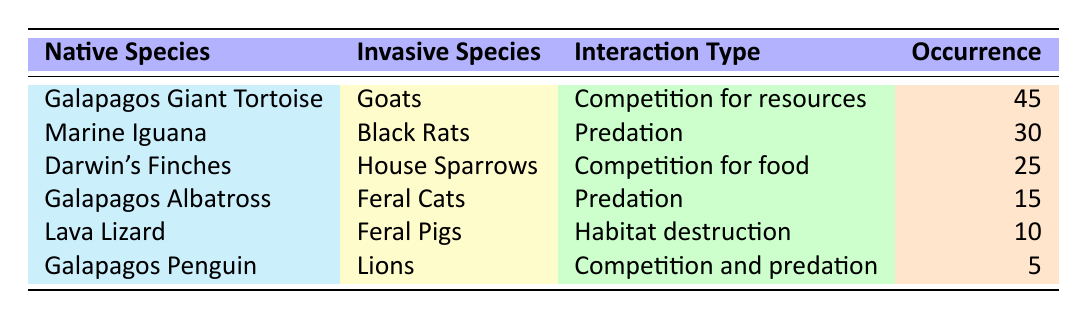What is the most common interaction type listed in the table? The interaction with the highest occurrence is "Competition for resources" between the Galapagos Giant Tortoise and Goats, which has an occurrence of 45. This is more than any other interaction listed.
Answer: Competition for resources How many occurrences are attributed to predation interactions? There are two predation interactions in the table: Marine Iguana with Black Rats (30 occurrences) and Galapagos Albatross with Feral Cats (15 occurrences). Adding these together gives 30 + 15 = 45 occurrences for predation.
Answer: 45 Is it true that invasive species cause habitat destruction for native species in the Galapagos? Yes, it is true, as indicated by the interaction between Lava Lizard and Feral Pigs, which is labeled as "Habitat destruction."
Answer: Yes Which native species has the least reported occurrences in interactions with invasive species? The Galapagos Penguin has the least occurrences with only 5, listed under the interaction "Competition and predation" with Lions.
Answer: Galapagos Penguin What is the total number of occurrences for all types of interactions in the table? To find the total occurrences, we add up occurrences from all interactions: 45 (Giant Tortoise) + 30 (Marine Iguana) + 25 (Darwin's Finches) + 15 (Galapagos Albatross) + 10 (Lava Lizard) + 5 (Galapagos Penguin) = 130.
Answer: 130 Do the data show that House Sparrows interact with more native species than Black Rats? No, the table shows that House Sparrows interact only with Darwin's Finches, while Black Rats interact with Marine Iguanas, indicating that Black Rats have one more interaction compared to House Sparrows.
Answer: No What percentage of the total occurrences are attributed to the competition interactions? There are three interactions that describe competition: Galapagos Giant Tortoise with Goats (45), Darwin's Finches with House Sparrows (25), and Galapagos Penguin with Lions (5). Summing these gives 45 + 25 + 5 = 75 occurrences. The total occurrences are 130, so the percentage of competition interactions is (75/130) * 100 ≈ 57.69%.
Answer: Approximately 57.69% Which invasive species is associated with the most occurrences across interactions? The invasive species associated with the most occurrences is Goats, which interacts with the Galapagos Giant Tortoise, having 45 occurrences.
Answer: Goats How many native species are involved in interactions with invasive species that lead to predation? There are two native species involved in predation: Marine Iguana (with Black Rats) and Galapagos Albatross (with Feral Cats). Therefore, there are 2 native species involved.
Answer: 2 